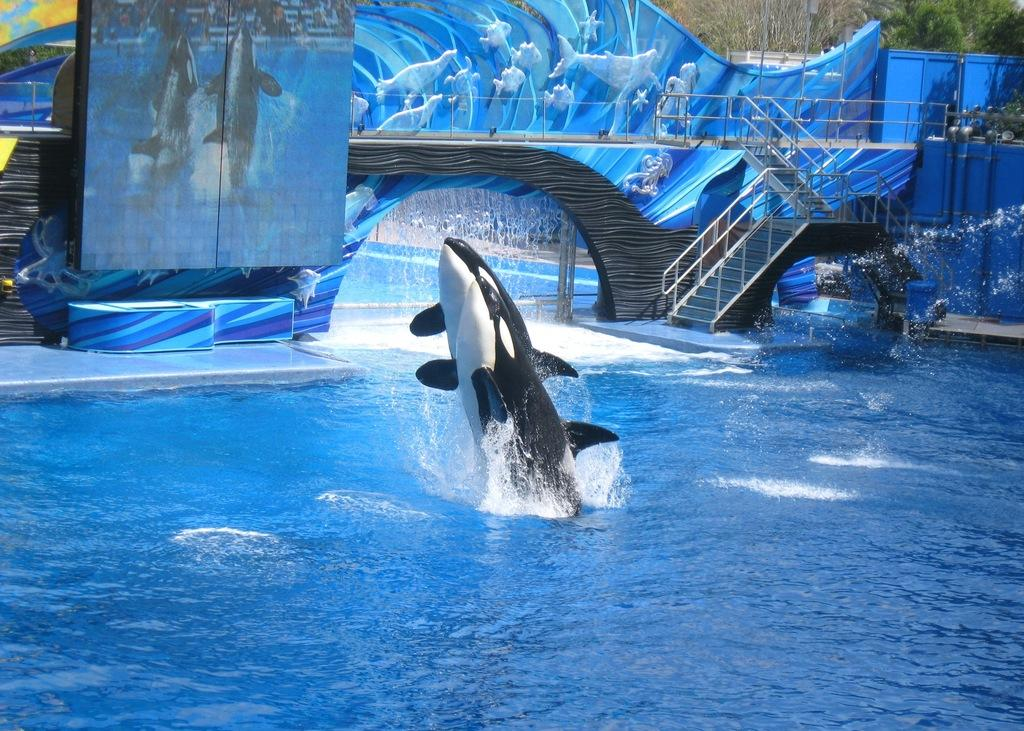What animals can be seen in the pool in the image? There are two dolphins in the pool. What is visible in the background of the image? There is a wall and stairs visible in the background of the image. What type of silk is being used to control the dolphins' movements in the image? There is no silk or control mechanism present in the image; the dolphins are swimming freely in the pool. 